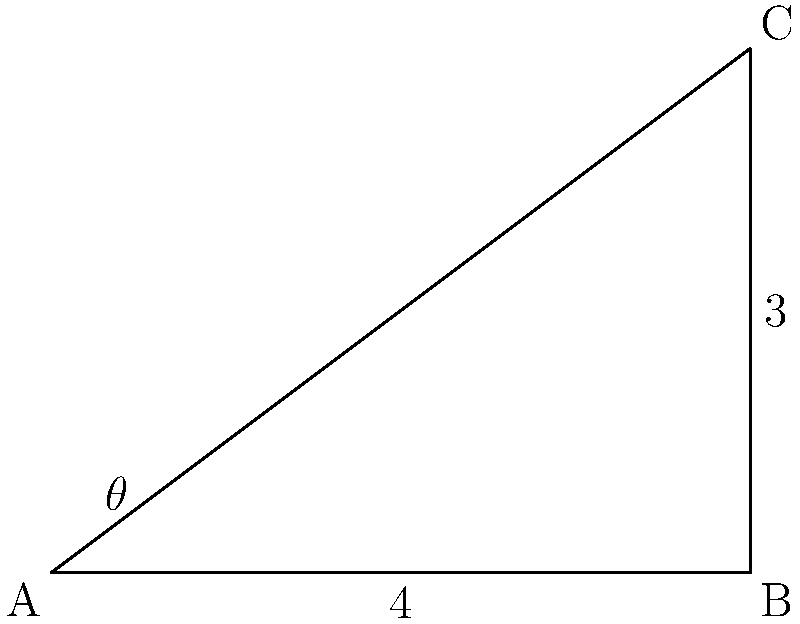As you reach for a book on the top shelf of the mobile library, your arm forms a right triangle with the bookshelf. If the shelf is 3 feet high and your arm extends 4 feet horizontally to reach the book, what is the angle $\theta$ between your arm and the shelf? Let's approach this step-by-step:

1) The scenario forms a right triangle, where:
   - The vertical side (shelf height) is 3 feet
   - The horizontal side (arm's horizontal reach) is 4 feet
   - The hypotenuse is your outstretched arm
   - The angle $\theta$ is what we need to find

2) We can use the trigonometric function tangent (tan) to find the angle:

   $\tan \theta = \frac{\text{opposite}}{\text{adjacent}} = \frac{3}{4}$

3) To find $\theta$, we need to use the inverse tangent function (arctan or $\tan^{-1}$):

   $\theta = \tan^{-1}(\frac{3}{4})$

4) Using a calculator or trigonometric tables:

   $\theta \approx 36.87°$

5) Rounding to the nearest degree:

   $\theta \approx 37°$
Answer: $37°$ 